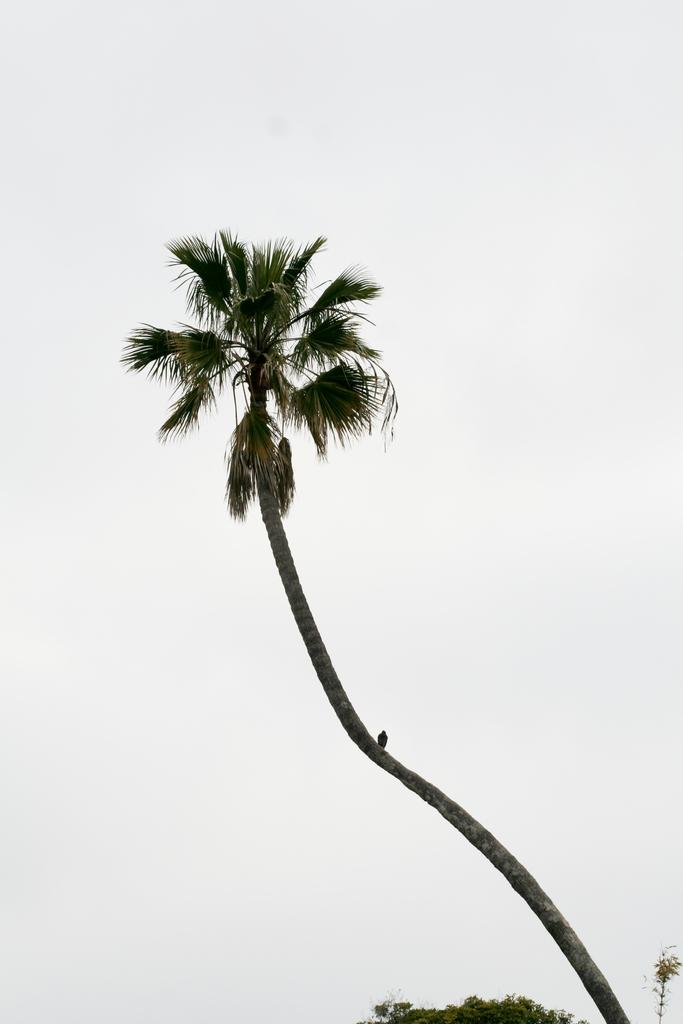What type of animal is in the image? There is a bird in the image. Where is the bird located? The bird is on a tree. What color are the leaves on the tree? The leaves in the image are green. What color is the background of the image? The background of the image is white. What type of house is visible in the image? There is no house present in the image; it features a bird on a tree with green leaves and a white background. 